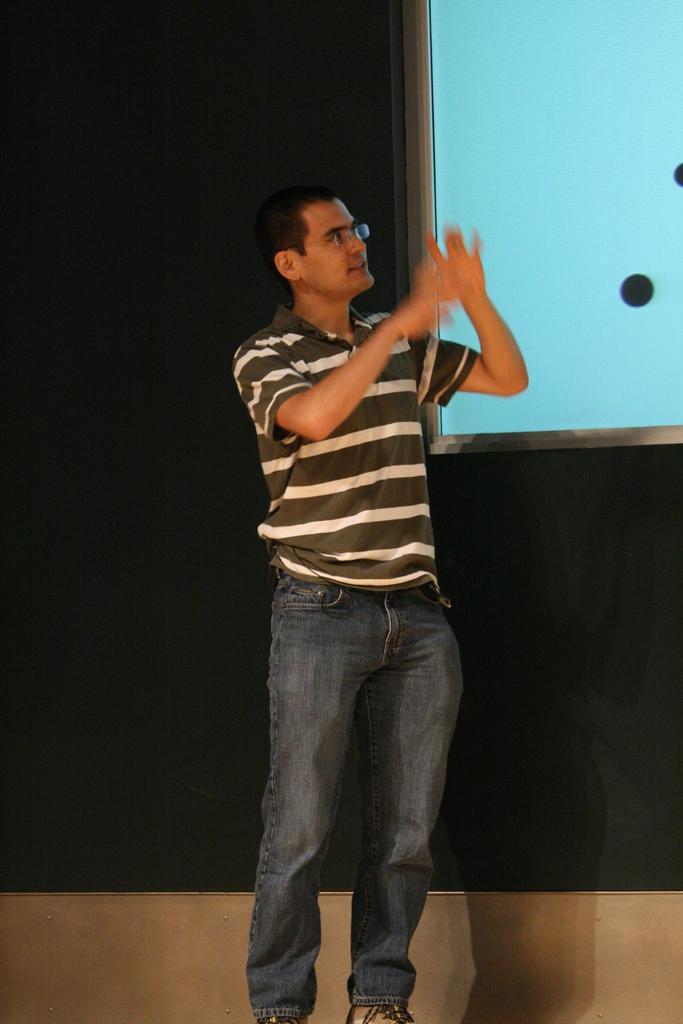Describe this image in one or two sentences. In this picture I can see a man in the middle, he is wearing a t-shirt, on the right side it looks like a projector screen. 